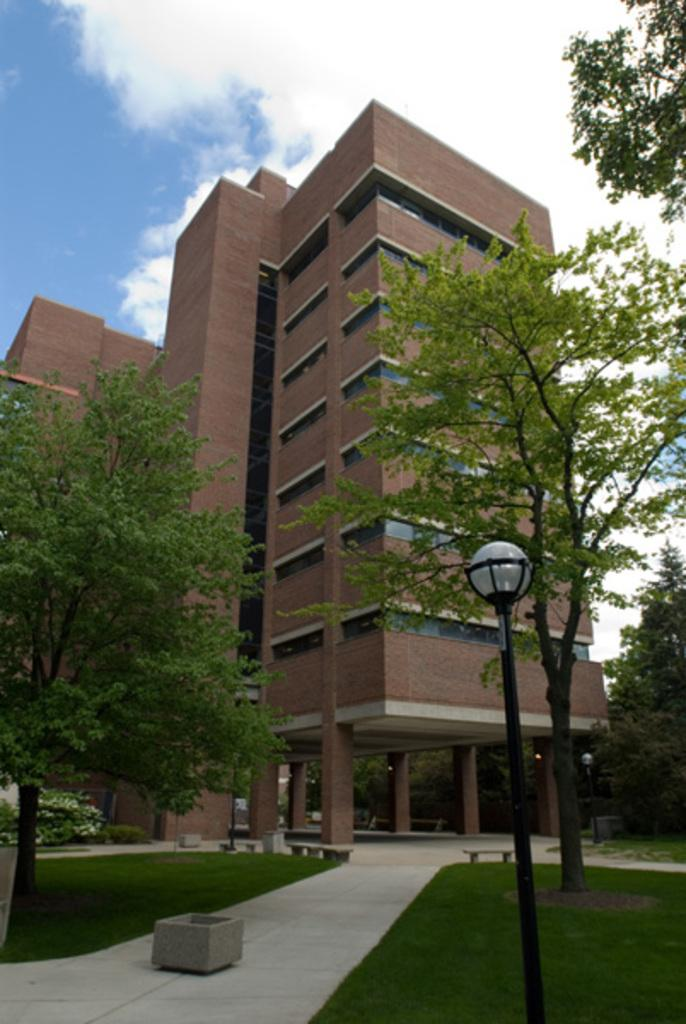What type of vegetation can be seen in the image? There is grass in the image. What type of structures are present in the image? There are square cement pots and benches in the image. What type of lighting is present in the image? There are lights in the image. What type of poles are present in the image? There are poles in the image. What type of building is present in the image? There is a building in the image. What type of trees can be seen in the image? There are trees in the image. What is visible in the background of the image? The sky is visible in the background of the image. Where is the tiger sitting in the image? There is no tiger present in the image. What type of form is being filled out in the lunchroom in the image? There is no lunchroom or form present in the image. 